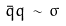<formula> <loc_0><loc_0><loc_500><loc_500>\bar { q } q \, \sim \, \sigma</formula> 